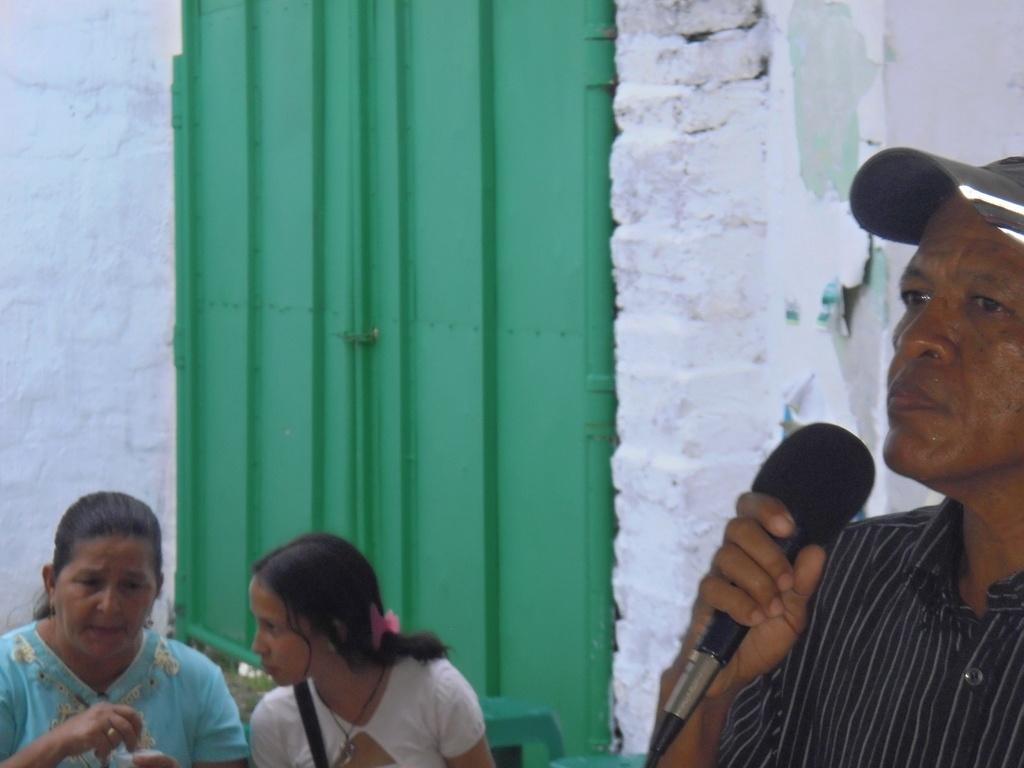How many people are in the image? There are two women and a man in the image. What is the man holding in the image? The man is holding a mic. Can you describe the man's attire in the image? The man is wearing a cap. What type of oatmeal is the man eating in the image? There is no oatmeal present in the image; the man is holding a mic. Can you describe the stranger in the image? There is no stranger present in the image; the three people are identified as two women and a man. 